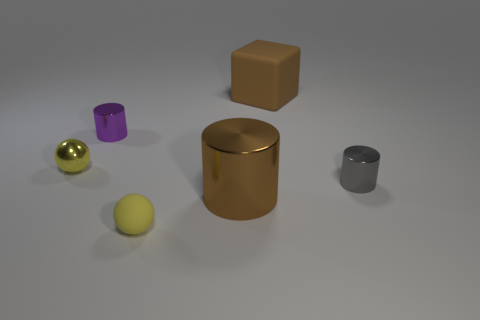Add 1 green shiny blocks. How many objects exist? 7 Subtract all large cylinders. How many cylinders are left? 2 Subtract all spheres. How many objects are left? 4 Subtract all purple cylinders. How many cylinders are left? 2 Subtract 1 yellow balls. How many objects are left? 5 Subtract 3 cylinders. How many cylinders are left? 0 Subtract all blue cubes. Subtract all cyan spheres. How many cubes are left? 1 Subtract all brown cylinders. How many gray balls are left? 0 Subtract all metallic objects. Subtract all small gray rubber balls. How many objects are left? 2 Add 2 gray things. How many gray things are left? 3 